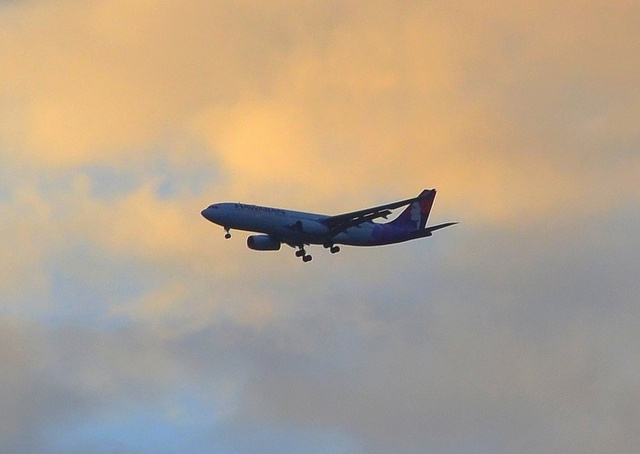Describe the objects in this image and their specific colors. I can see a airplane in darkgray, black, navy, and darkblue tones in this image. 